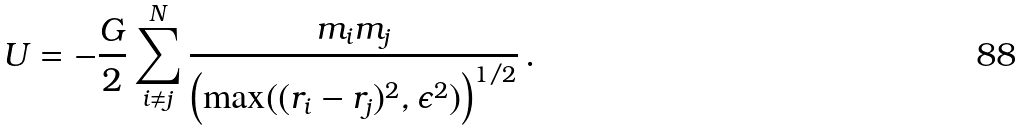<formula> <loc_0><loc_0><loc_500><loc_500>U = - \frac { G } { 2 } \sum _ { i \neq j } ^ { N } \frac { m _ { i } m _ { j } } { \left ( \max ( ( r _ { i } - r _ { j } ) ^ { 2 } , \epsilon ^ { 2 } ) \right ) ^ { 1 / 2 } } \, .</formula> 